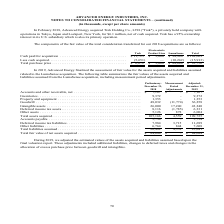According to Advanced Energy's financial document, What did the company's adjustment to the estimated values of the assets acquired and liabilities assumed  in 2019 include? additional liabilities, changes to deferred taxes and changes in the allocation of excess purchase price between goodwill and intangibles.. The document states: "final valuation report. These adjustments included additional liabilities, changes to deferred taxes and changes in the allocation of excess purchase ..." Also, What was the Preliminary fair value of inventories in 2018? According to the financial document, 9,372 (in thousands). The relevant text states: "Inventories . 9,372 - 9,372 Property and equipment . 1,353 - 1,353 Goodwill . 48,032 (11,774) 36,258 Intangible assets..." Also, What was the Adjusted fair value of Goodwill in 2019? According to the financial document, 36,258 (in thousands). The relevant text states: "ipment . 1,353 - 1,353 Goodwill . 48,032 (11,774) 36,258 Intangible assets . 26,000 17,240 43,240 Deferred income tax assets . 8,116 (1,785) 6,331 Other ass..." Also, can you calculate: What was the percentage change in the fair value of Goodwill between 2018 and 2019? To answer this question, I need to perform calculations using the financial data. The calculation is: (36,258-48,032)/48,032, which equals -24.51 (percentage). This is based on the information: "ipment . 1,353 - 1,353 Goodwill . 48,032 (11,774) 36,258 Intangible assets . 26,000 17,240 43,240 Deferred income tax assets . 8,116 (1,785) 6,331 Other ass Property and equipment . 1,353 - 1,353 Good..." The key data points involved are: 36,258, 48,032. Also, can you calculate: What was the percentage change in the fair value of intangible assets between 2018 and 2019? To answer this question, I need to perform calculations using the financial data. The calculation is: (43,240-26,000)/26,000, which equals 66.31 (percentage). This is based on the information: "will . 48,032 (11,774) 36,258 Intangible assets . 26,000 17,240 43,240 Deferred income tax assets . 8,116 (1,785) 6,331 Other assets . 5,126 878 6,004 Total (11,774) 36,258 Intangible assets . 26,000 ..." The key data points involved are: 26,000, 43,240. Also, can you calculate: What was the percentage change in the fair value of deferred income tax assets between 2018 and 2019? To answer this question, I need to perform calculations using the financial data. The calculation is: (6,331-8,116)/8,116, which equals -21.99 (percentage). This is based on the information: "26,000 17,240 43,240 Deferred income tax assets . 8,116 (1,785) 6,331 Other assets . 5,126 878 6,004 Total assets acquired . 105,166 4,559 109,725 43,240 Deferred income tax assets . 8,116 (1,785) 6,3..." The key data points involved are: 6,331, 8,116. 